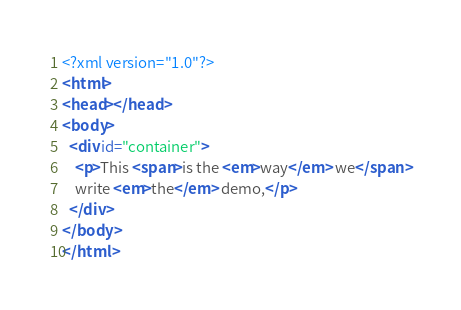<code> <loc_0><loc_0><loc_500><loc_500><_XML_><?xml version="1.0"?>
<html>
<head></head>
<body>
  <div id="container">
    <p>This <span>is the <em>way</em> we</span>
    write <em>the</em> demo,</p>
  </div>
</body>
</html></code> 